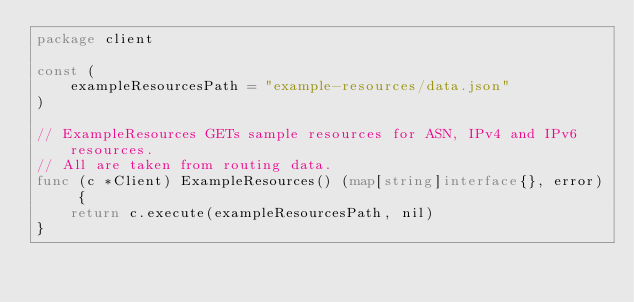Convert code to text. <code><loc_0><loc_0><loc_500><loc_500><_Go_>package client

const (
	exampleResourcesPath = "example-resources/data.json"
)

// ExampleResources GETs sample resources for ASN, IPv4 and IPv6 resources.
// All are taken from routing data.
func (c *Client) ExampleResources() (map[string]interface{}, error) {
	return c.execute(exampleResourcesPath, nil)
}
</code> 